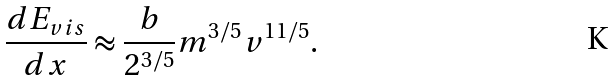Convert formula to latex. <formula><loc_0><loc_0><loc_500><loc_500>\frac { d E _ { v i s } } { d x } \approx \frac { b } { 2 ^ { 3 / 5 } } m ^ { 3 / 5 } v ^ { 1 1 / 5 } .</formula> 